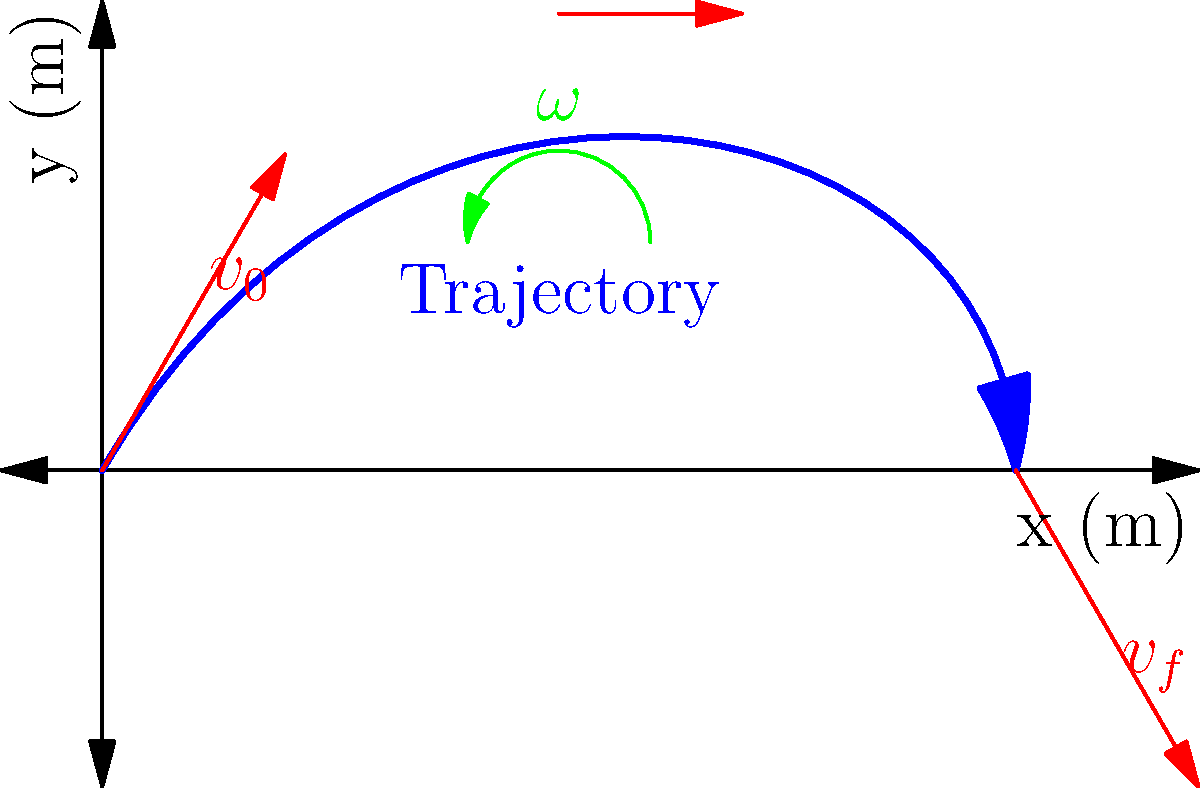A badminton player executes a smash shot, launching the shuttlecock with an initial velocity of 50 m/s at a 60° angle above the horizontal. The shuttlecock experiences a spin of 100 rad/s throughout its flight. Assuming negligible air resistance, calculate the horizontal distance traveled by the shuttlecock when it returns to its initial height. How does the spin of the shuttlecock affect its trajectory? To solve this problem, we'll follow these steps:

1) First, let's identify the known variables:
   - Initial velocity, $v_0 = 50$ m/s
   - Launch angle, $\theta = 60°$
   - Angular velocity, $\omega = 100$ rad/s
   - Initial and final heights are the same (y = 0)

2) We can split the initial velocity into its x and y components:
   $v_{0x} = v_0 \cos(\theta) = 50 \cos(60°) = 25$ m/s
   $v_{0y} = v_0 \sin(\theta) = 50 \sin(60°) = 43.3$ m/s

3) The time of flight can be calculated using the equation:
   $y = y_0 + v_{0y}t - \frac{1}{2}gt^2$
   At the final position, y = 0, so:
   $0 = 0 + 43.3t - \frac{1}{2}(9.8)t^2$
   $4.9t^2 - 43.3t = 0$
   $t(4.9t - 43.3) = 0$
   $t = 0$ or $t = 8.84$ s (we take the non-zero solution)

4) Now we can calculate the horizontal distance:
   $x = v_{0x}t = 25 * 8.84 = 221$ m

5) Regarding the spin's effect on the trajectory:
   The spin of the shuttlecock creates a Magnus force perpendicular to both the direction of motion and the axis of rotation. In this case, it would create a downward force, slightly reducing the height of the trajectory and the total distance traveled. However, this effect was not considered in our calculation as we assumed negligible air resistance.

6) In reality, the spin would also help stabilize the shuttlecock's flight, maintaining its orientation and reducing wobble, which is crucial for accurate shots in badminton.
Answer: 221 m; spin creates downward force, slightly reducing trajectory height and distance, while stabilizing flight. 